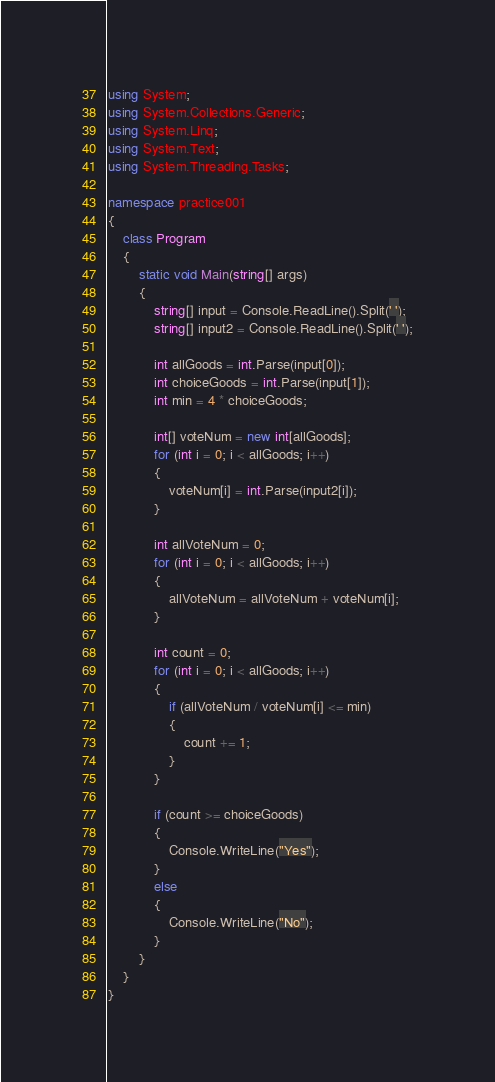<code> <loc_0><loc_0><loc_500><loc_500><_C#_>using System;
using System.Collections.Generic;
using System.Linq;
using System.Text;
using System.Threading.Tasks;

namespace practice001
{
    class Program
    {
        static void Main(string[] args)
        {
            string[] input = Console.ReadLine().Split(' ');
            string[] input2 = Console.ReadLine().Split(' ');

            int allGoods = int.Parse(input[0]);
            int choiceGoods = int.Parse(input[1]);
            int min = 4 * choiceGoods;

            int[] voteNum = new int[allGoods];
            for (int i = 0; i < allGoods; i++)
            {
                voteNum[i] = int.Parse(input2[i]);
            }

            int allVoteNum = 0;
            for (int i = 0; i < allGoods; i++)
            {
                allVoteNum = allVoteNum + voteNum[i];
            }

            int count = 0;
            for (int i = 0; i < allGoods; i++)
            {
                if (allVoteNum / voteNum[i] <= min)
                {
                    count += 1;
                }
            }

            if (count >= choiceGoods)
            {
                Console.WriteLine("Yes");
            }
            else
            {
                Console.WriteLine("No");
            }
        }
    }
}</code> 